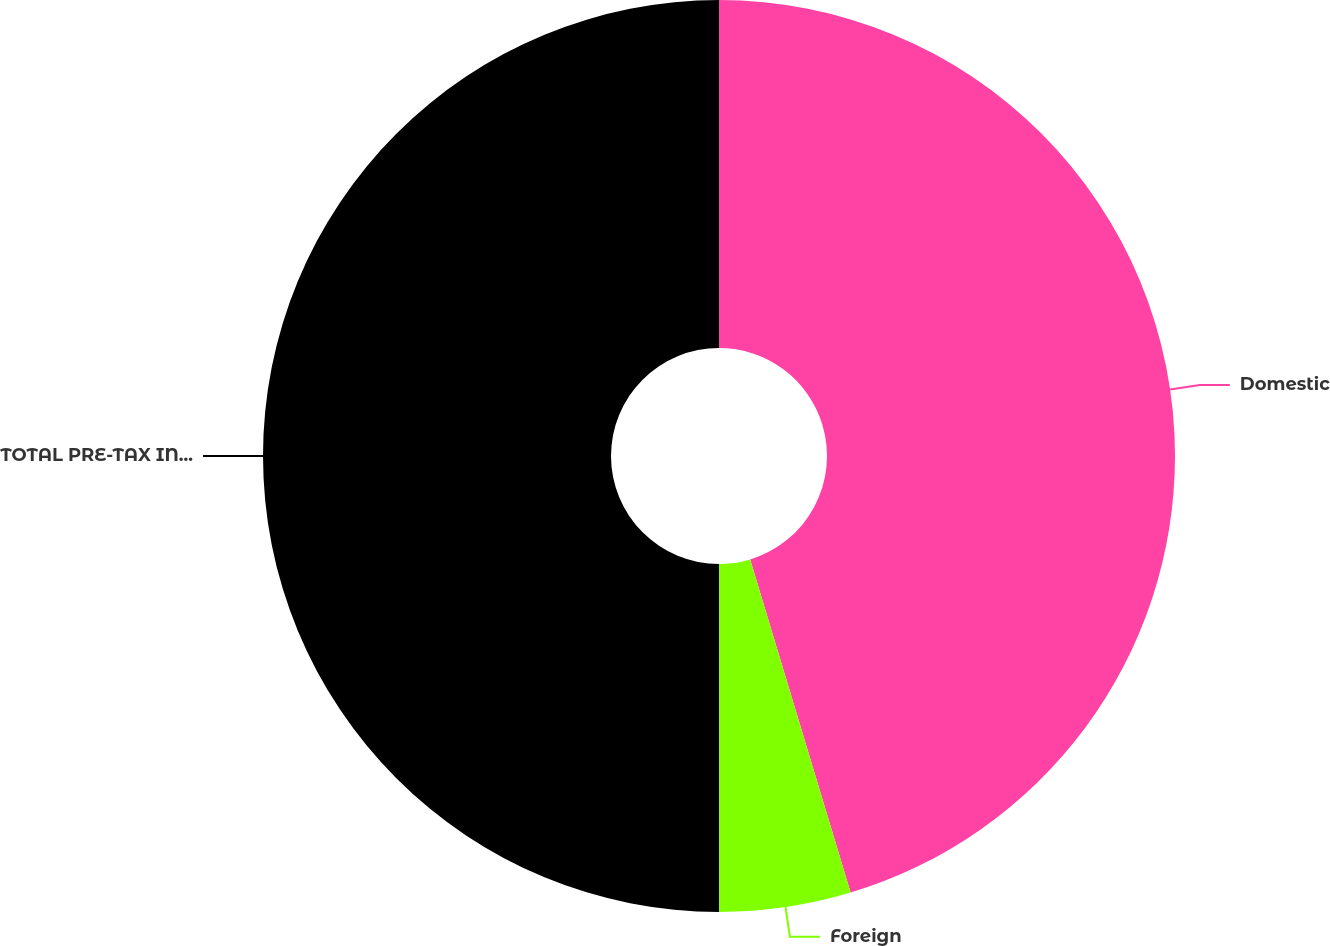Convert chart. <chart><loc_0><loc_0><loc_500><loc_500><pie_chart><fcel>Domestic<fcel>Foreign<fcel>TOTAL PRE-TAX INCOME<nl><fcel>45.34%<fcel>4.66%<fcel>50.0%<nl></chart> 